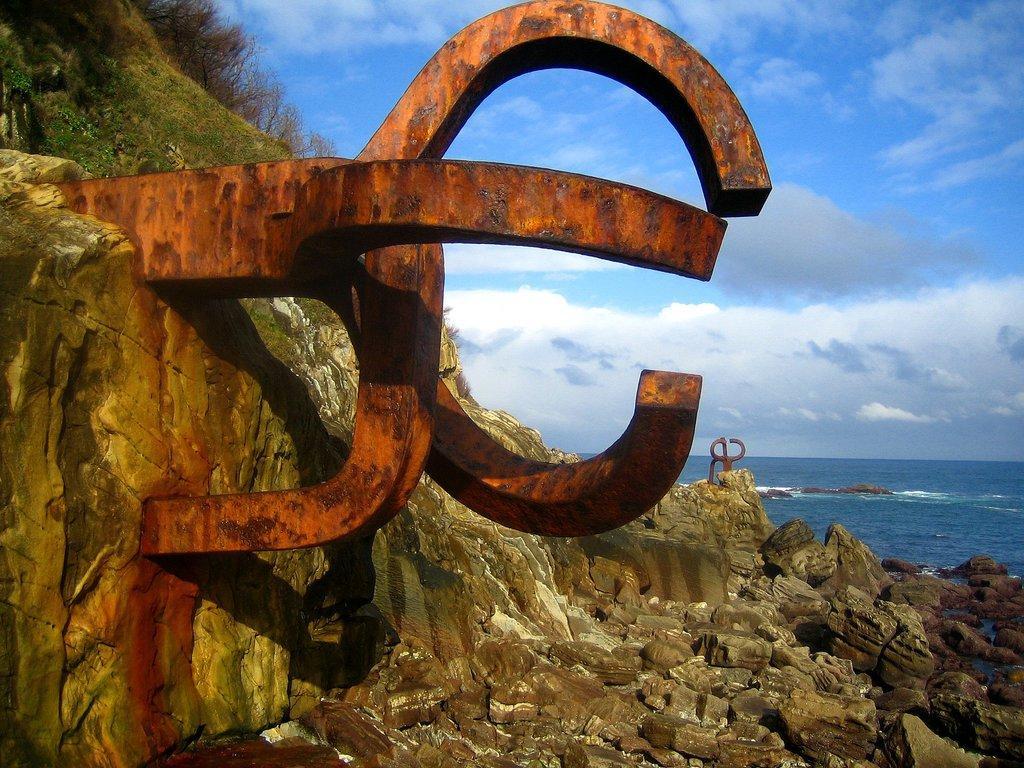Please provide a concise description of this image. In this image I can see a rocky mountain, few trees on the mountain and few metal objects which are orange, brown and black in color. In the background I can see the water and the sky. 